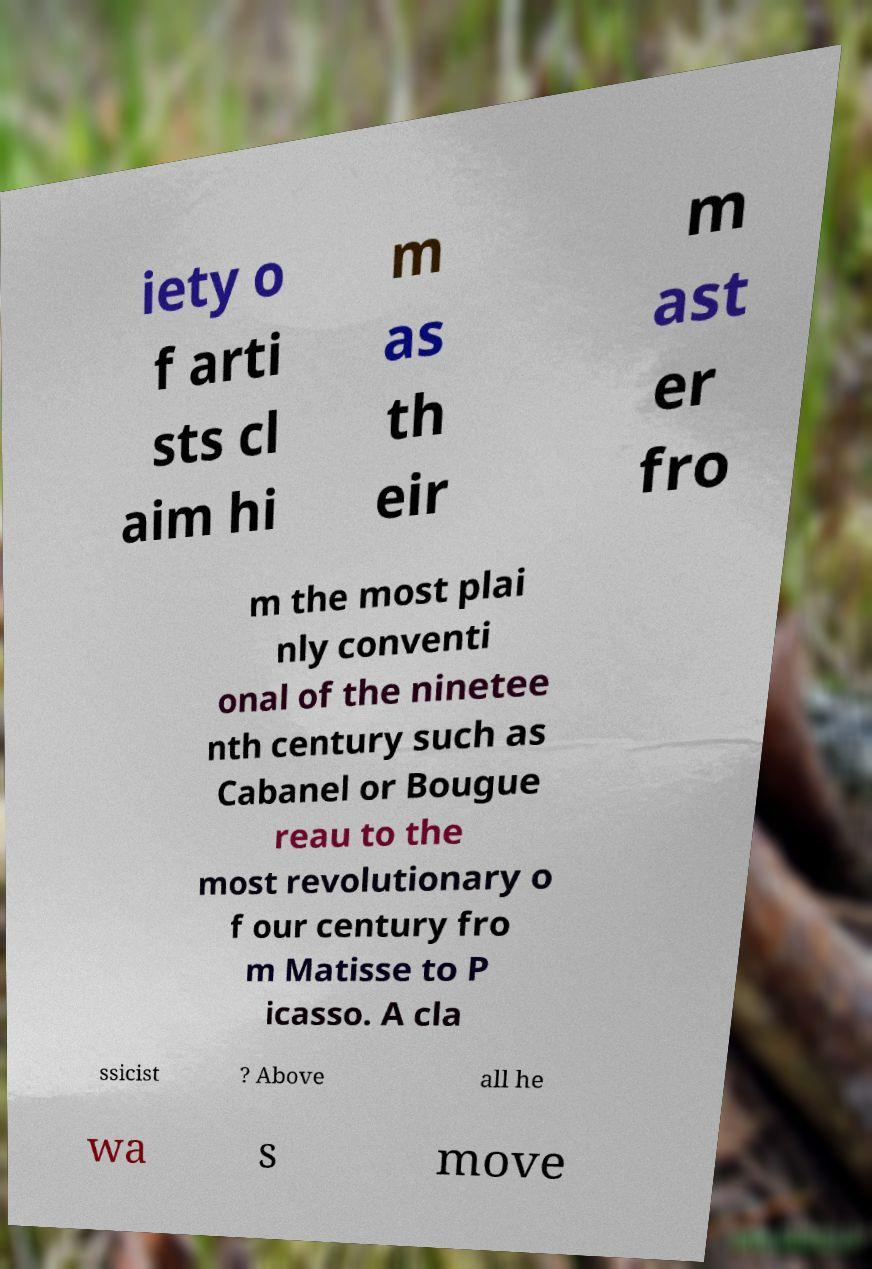Can you accurately transcribe the text from the provided image for me? iety o f arti sts cl aim hi m as th eir m ast er fro m the most plai nly conventi onal of the ninetee nth century such as Cabanel or Bougue reau to the most revolutionary o f our century fro m Matisse to P icasso. A cla ssicist ? Above all he wa s move 